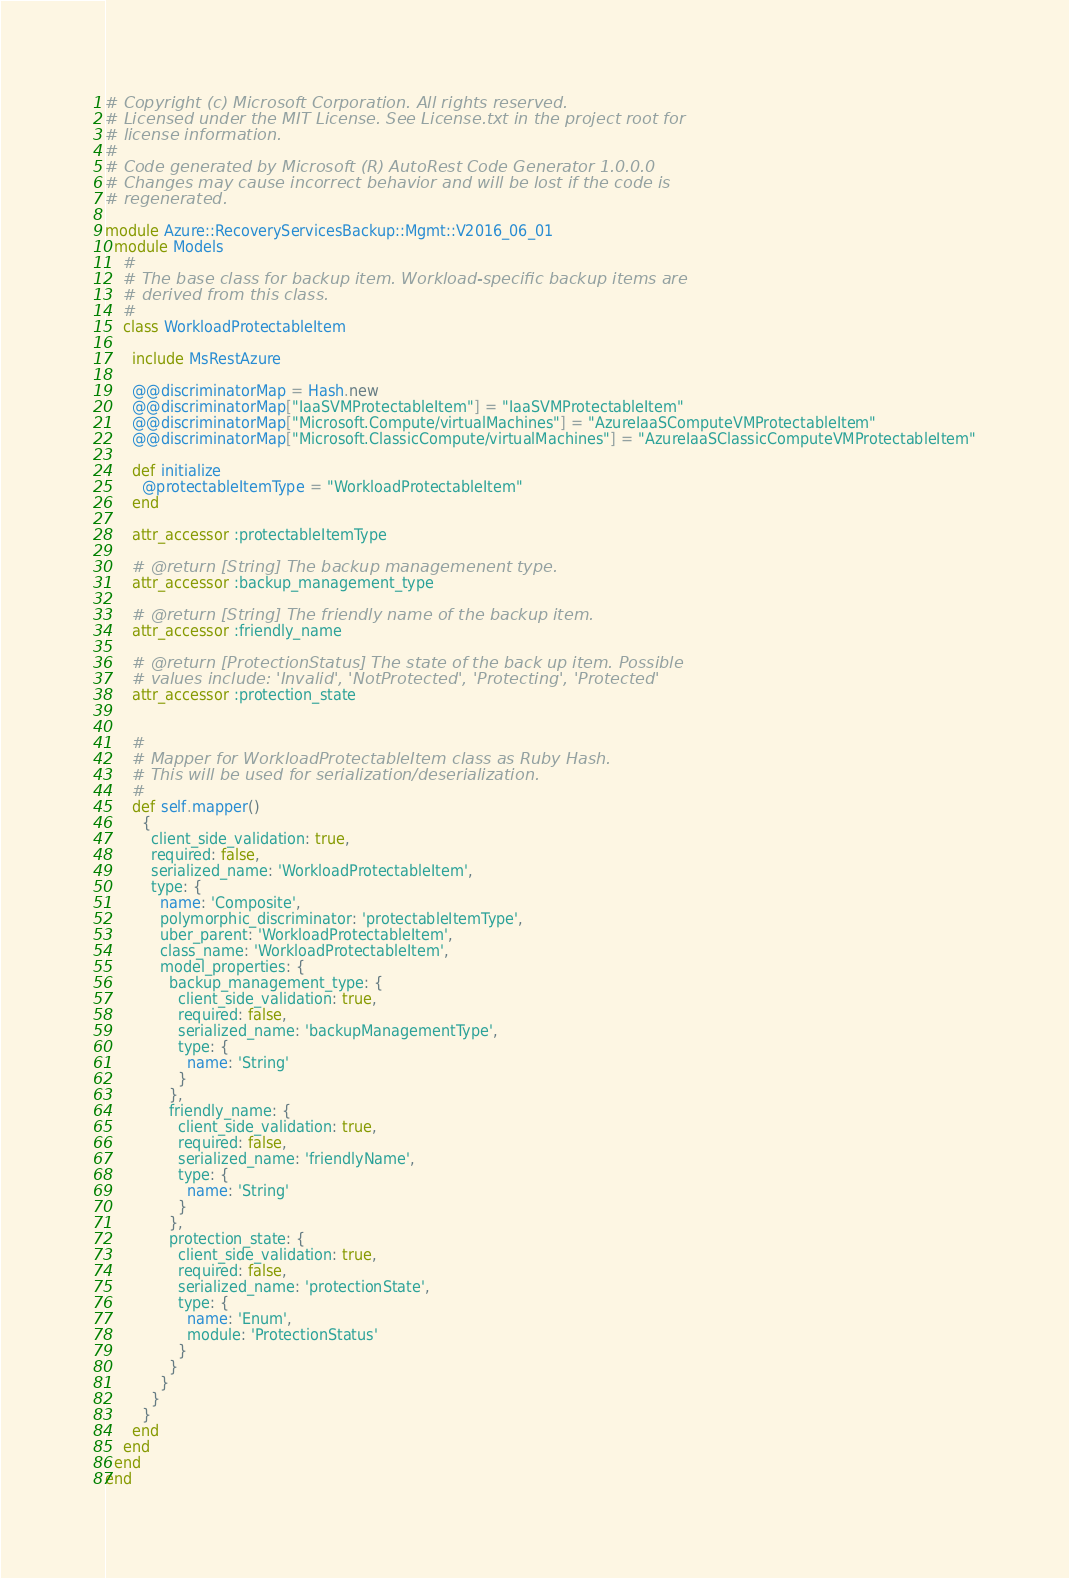Convert code to text. <code><loc_0><loc_0><loc_500><loc_500><_Ruby_># Copyright (c) Microsoft Corporation. All rights reserved.
# Licensed under the MIT License. See License.txt in the project root for
# license information.
#
# Code generated by Microsoft (R) AutoRest Code Generator 1.0.0.0
# Changes may cause incorrect behavior and will be lost if the code is
# regenerated.

module Azure::RecoveryServicesBackup::Mgmt::V2016_06_01
  module Models
    #
    # The base class for backup item. Workload-specific backup items are
    # derived from this class.
    #
    class WorkloadProtectableItem

      include MsRestAzure

      @@discriminatorMap = Hash.new
      @@discriminatorMap["IaaSVMProtectableItem"] = "IaaSVMProtectableItem"
      @@discriminatorMap["Microsoft.Compute/virtualMachines"] = "AzureIaaSComputeVMProtectableItem"
      @@discriminatorMap["Microsoft.ClassicCompute/virtualMachines"] = "AzureIaaSClassicComputeVMProtectableItem"

      def initialize
        @protectableItemType = "WorkloadProtectableItem"
      end

      attr_accessor :protectableItemType

      # @return [String] The backup managemenent type.
      attr_accessor :backup_management_type

      # @return [String] The friendly name of the backup item.
      attr_accessor :friendly_name

      # @return [ProtectionStatus] The state of the back up item. Possible
      # values include: 'Invalid', 'NotProtected', 'Protecting', 'Protected'
      attr_accessor :protection_state


      #
      # Mapper for WorkloadProtectableItem class as Ruby Hash.
      # This will be used for serialization/deserialization.
      #
      def self.mapper()
        {
          client_side_validation: true,
          required: false,
          serialized_name: 'WorkloadProtectableItem',
          type: {
            name: 'Composite',
            polymorphic_discriminator: 'protectableItemType',
            uber_parent: 'WorkloadProtectableItem',
            class_name: 'WorkloadProtectableItem',
            model_properties: {
              backup_management_type: {
                client_side_validation: true,
                required: false,
                serialized_name: 'backupManagementType',
                type: {
                  name: 'String'
                }
              },
              friendly_name: {
                client_side_validation: true,
                required: false,
                serialized_name: 'friendlyName',
                type: {
                  name: 'String'
                }
              },
              protection_state: {
                client_side_validation: true,
                required: false,
                serialized_name: 'protectionState',
                type: {
                  name: 'Enum',
                  module: 'ProtectionStatus'
                }
              }
            }
          }
        }
      end
    end
  end
end
</code> 